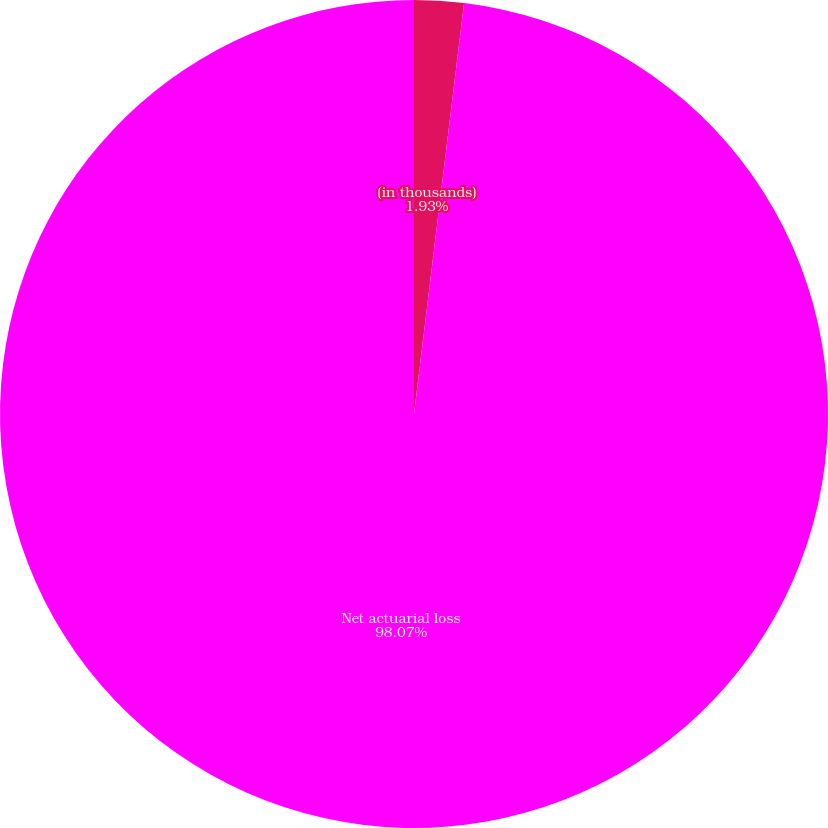<chart> <loc_0><loc_0><loc_500><loc_500><pie_chart><fcel>(in thousands)<fcel>Net actuarial loss<nl><fcel>1.93%<fcel>98.07%<nl></chart> 